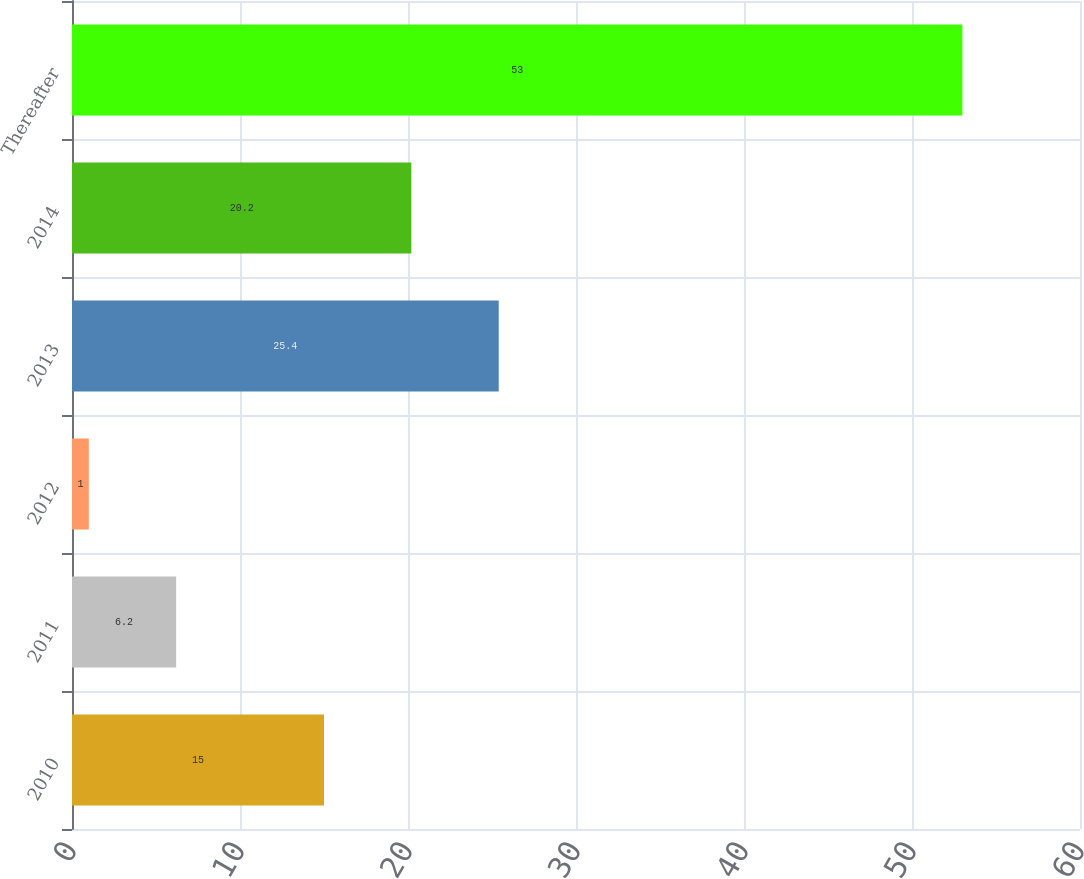<chart> <loc_0><loc_0><loc_500><loc_500><bar_chart><fcel>2010<fcel>2011<fcel>2012<fcel>2013<fcel>2014<fcel>Thereafter<nl><fcel>15<fcel>6.2<fcel>1<fcel>25.4<fcel>20.2<fcel>53<nl></chart> 